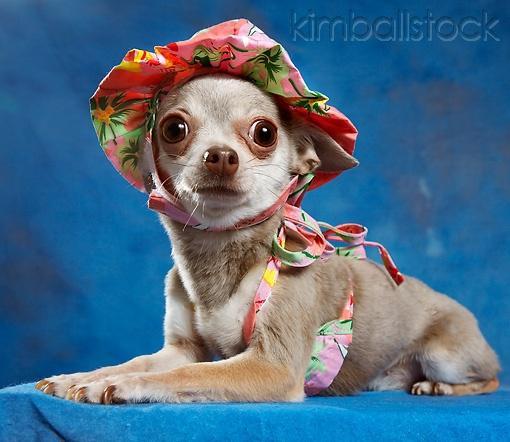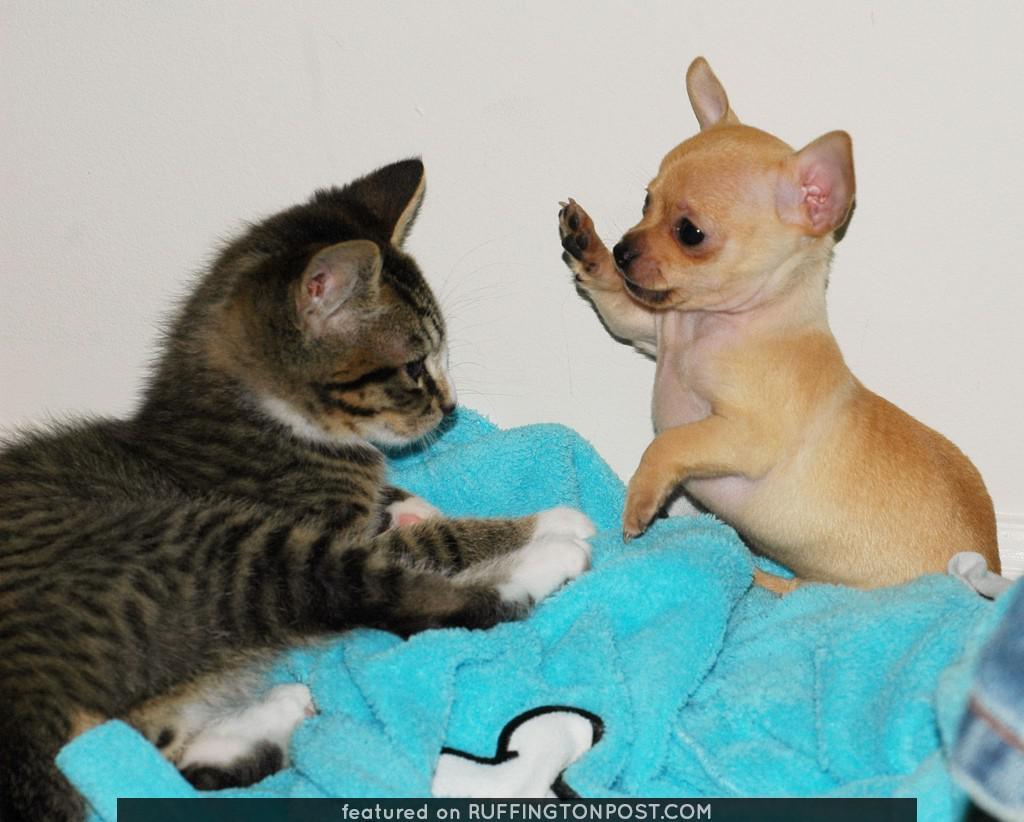The first image is the image on the left, the second image is the image on the right. Examine the images to the left and right. Is the description "The dog dressed in costume in the right hand image is photographed against a blue background." accurate? Answer yes or no. No. The first image is the image on the left, the second image is the image on the right. For the images shown, is this caption "The right image contains a dog wearing a small hat." true? Answer yes or no. No. 